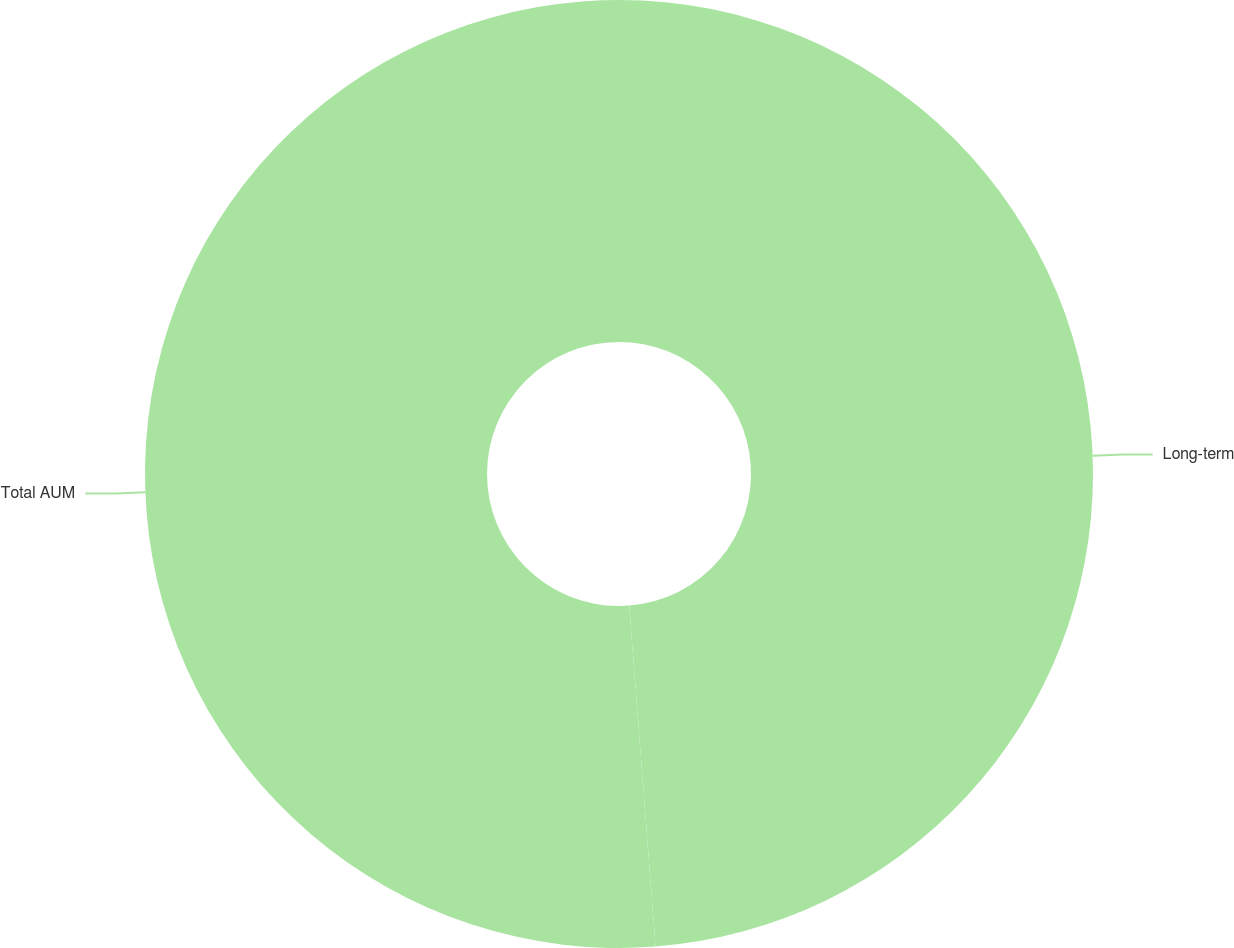Convert chart. <chart><loc_0><loc_0><loc_500><loc_500><pie_chart><fcel>Long-term<fcel>Total AUM<nl><fcel>48.77%<fcel>51.23%<nl></chart> 